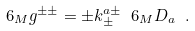<formula> <loc_0><loc_0><loc_500><loc_500>\ 6 _ { M } g ^ { \pm \pm } = \pm k _ { \pm } ^ { a \pm } \ 6 _ { M } D _ { a } \ .</formula> 